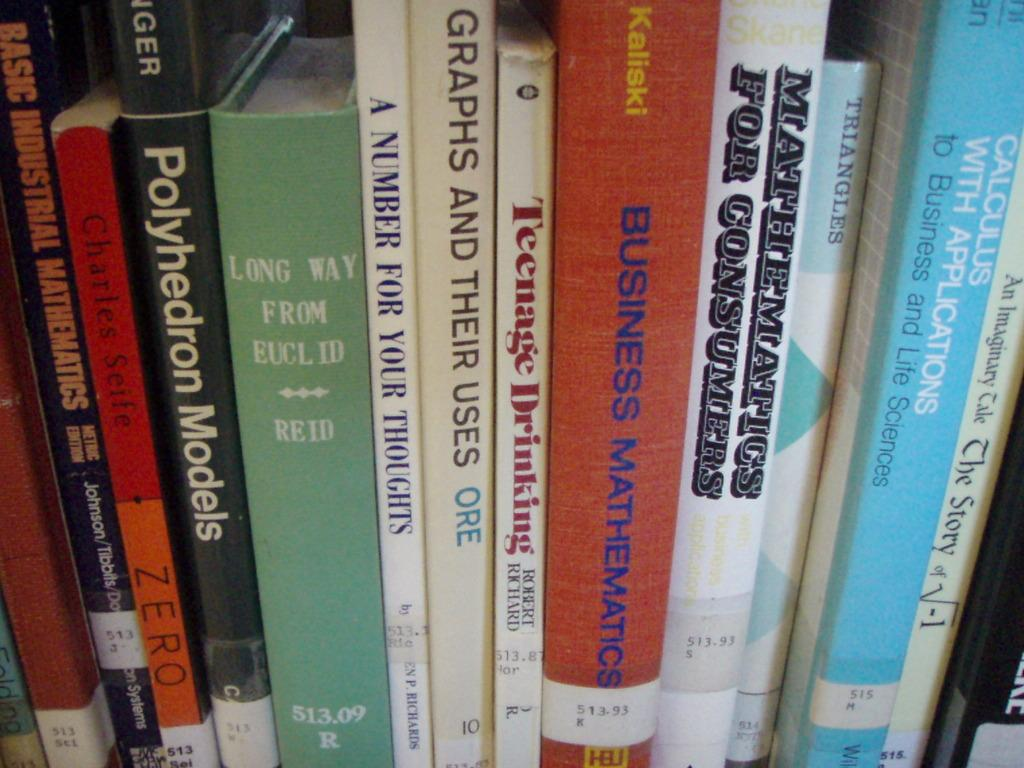<image>
Summarize the visual content of the image. In a row of books there is one on Teenage Drinking that's written by Robert Richard. 